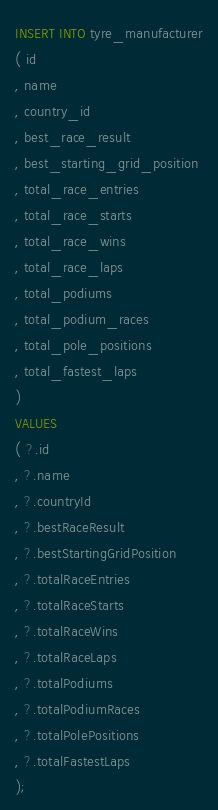<code> <loc_0><loc_0><loc_500><loc_500><_SQL_>INSERT INTO tyre_manufacturer
( id
, name
, country_id
, best_race_result
, best_starting_grid_position
, total_race_entries
, total_race_starts
, total_race_wins
, total_race_laps
, total_podiums
, total_podium_races
, total_pole_positions
, total_fastest_laps
)
VALUES
( ?.id
, ?.name
, ?.countryId
, ?.bestRaceResult
, ?.bestStartingGridPosition
, ?.totalRaceEntries
, ?.totalRaceStarts
, ?.totalRaceWins
, ?.totalRaceLaps
, ?.totalPodiums
, ?.totalPodiumRaces
, ?.totalPolePositions
, ?.totalFastestLaps
);
</code> 